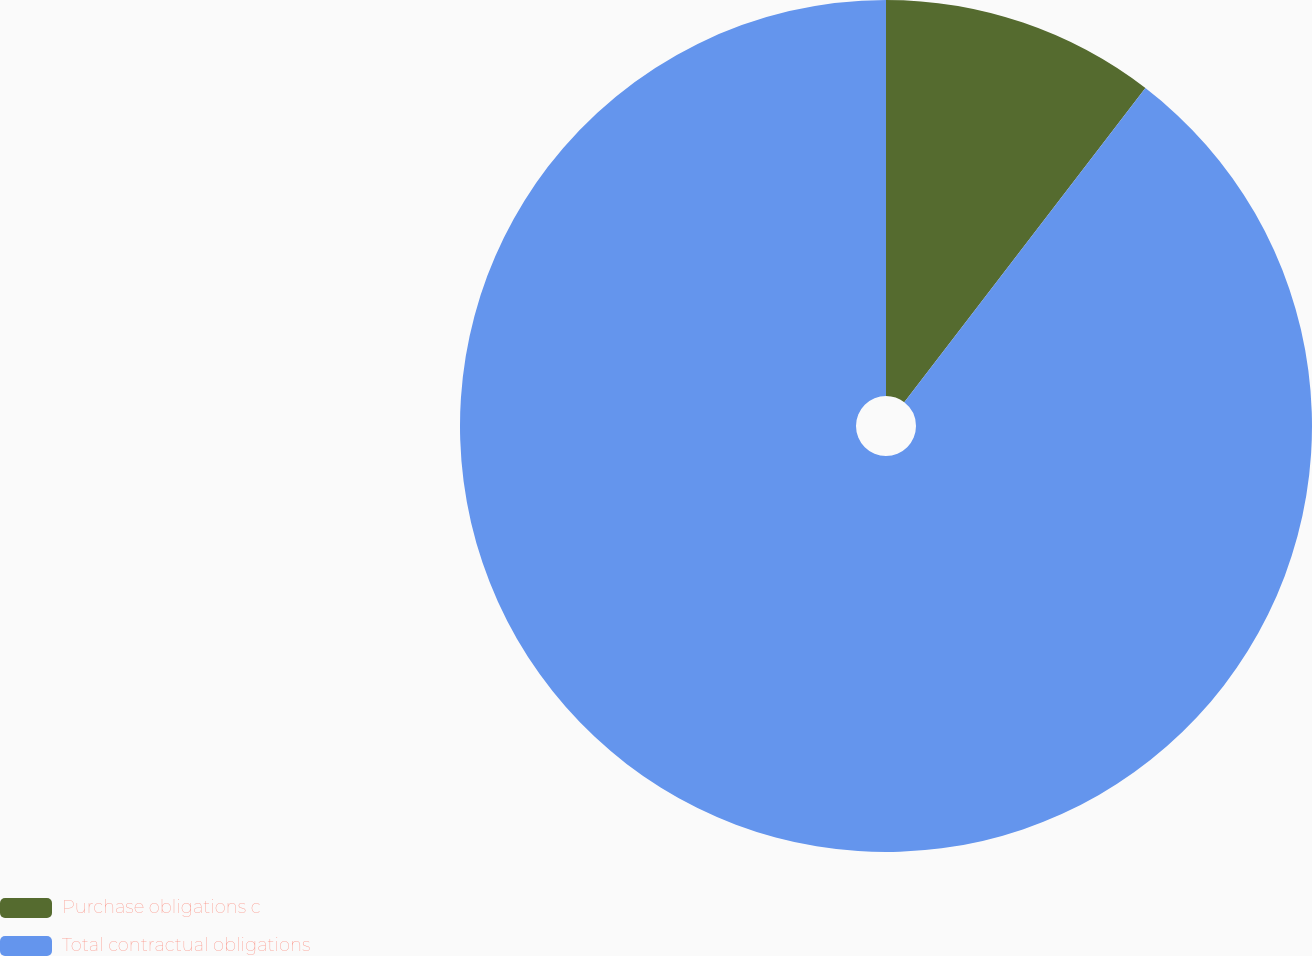Convert chart to OTSL. <chart><loc_0><loc_0><loc_500><loc_500><pie_chart><fcel>Purchase obligations c<fcel>Total contractual obligations<nl><fcel>10.42%<fcel>89.58%<nl></chart> 